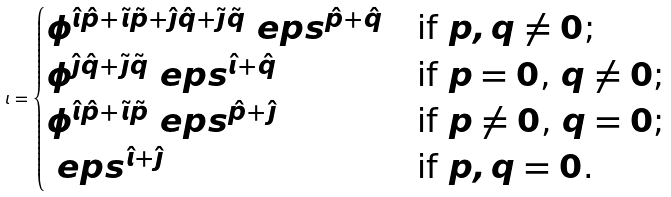Convert formula to latex. <formula><loc_0><loc_0><loc_500><loc_500>\iota = \begin{cases} \phi ^ { \hat { \imath } \hat { p } + \tilde { \imath } \tilde { p } + \hat { \jmath } \hat { q } + \tilde { \jmath } \tilde { q } } \ e p s ^ { \hat { p } + \hat { q } } & \text {if $p,q \ne 0$;} \\ \phi ^ { \hat { \jmath } \hat { q } + \tilde { \jmath } \tilde { q } } \ e p s ^ { \hat { \imath } + \hat { q } } & \text {if $p = 0$, $q \ne 0$;} \\ \phi ^ { \hat { \imath } \hat { p } + \tilde { \imath } \tilde { p } } \ e p s ^ { \hat { p } + \hat { \jmath } } & \text {if $p \ne 0$, $q = 0$;} \\ \ e p s ^ { \hat { \imath } + \hat { \jmath } } & \text {if $p,q = 0$.} \end{cases}</formula> 